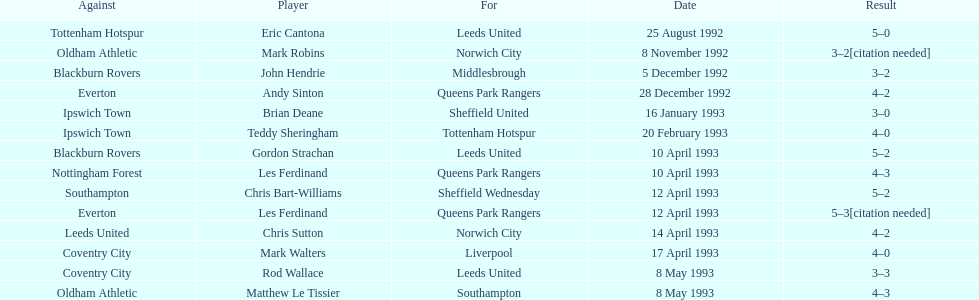Southampton played on may 8th, 1993, who was their opponent? Oldham Athletic. 